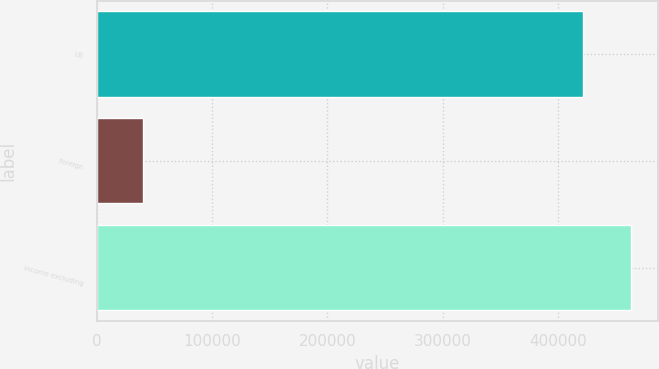Convert chart. <chart><loc_0><loc_0><loc_500><loc_500><bar_chart><fcel>US<fcel>Foreign<fcel>Income excluding<nl><fcel>421662<fcel>39585<fcel>463828<nl></chart> 